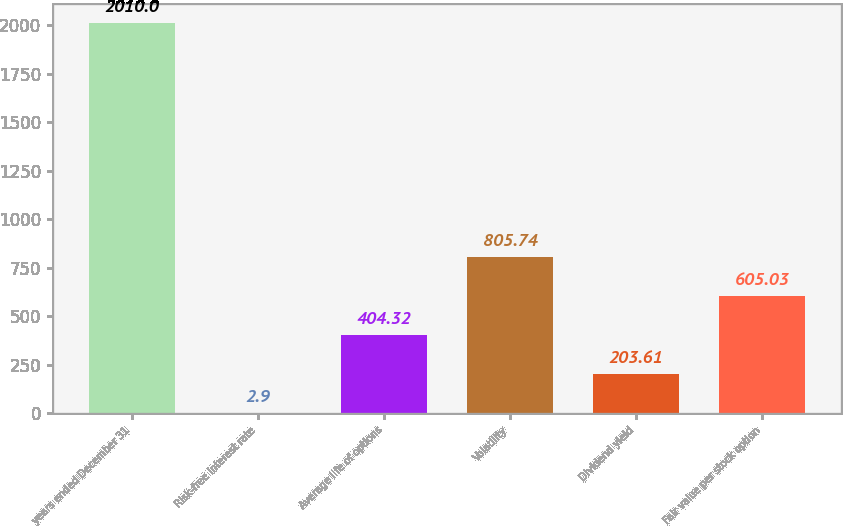<chart> <loc_0><loc_0><loc_500><loc_500><bar_chart><fcel>years ended December 31<fcel>Risk-free interest rate<fcel>Average life of options<fcel>Volatility<fcel>Dividend yield<fcel>Fair value per stock option<nl><fcel>2010<fcel>2.9<fcel>404.32<fcel>805.74<fcel>203.61<fcel>605.03<nl></chart> 